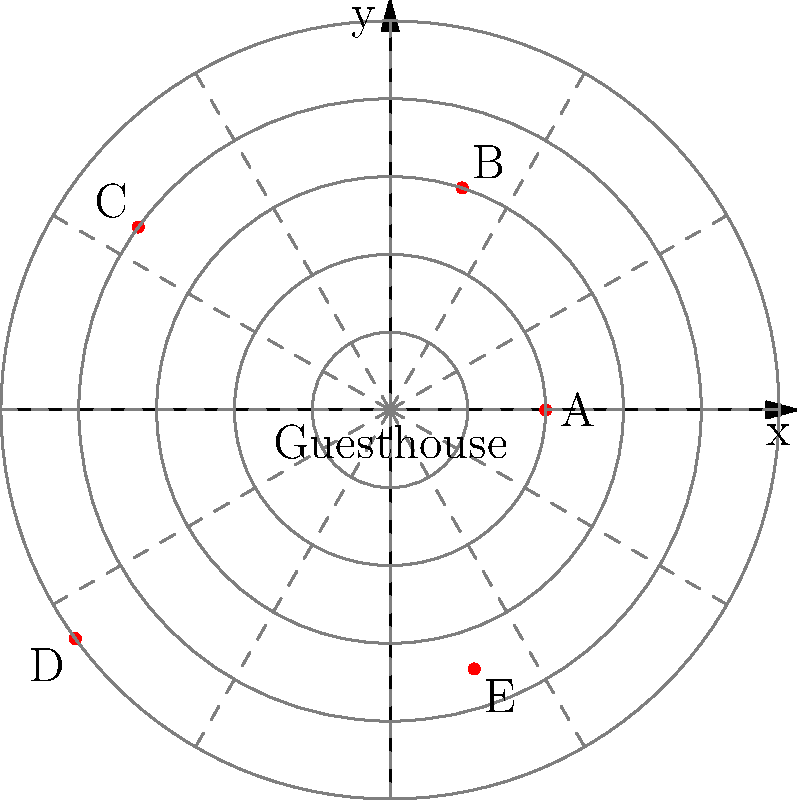The polar coordinate map shows the locations of five tourist attractions (A, B, C, D, and E) relative to your guesthouse at the origin. Each concentric circle represents a distance of 1 km. Which tourist attraction is located at coordinates $(r, \theta) = (4, 144^\circ)$? To find the tourist attraction at $(r, \theta) = (4, 144^\circ)$, we need to follow these steps:

1. Understand the given coordinates:
   - $r = 4$ means the attraction is 4 km away from the guesthouse
   - $\theta = 144^\circ$ indicates the angle from the positive x-axis

2. Examine the map:
   - The concentric circles represent distances in 1 km increments
   - The dashed lines represent angles in 30° increments

3. Locate the point $(4, 144^\circ)$ on the map:
   - Move 4 units (4 km) from the center
   - The angle 144° is between the 120° and 150° dashed lines, closer to 150°

4. Identify the tourist attraction at this location:
   - The red dot at this position is labeled "C"

Therefore, the tourist attraction located at coordinates $(r, \theta) = (4, 144^\circ)$ is C.
Answer: C 